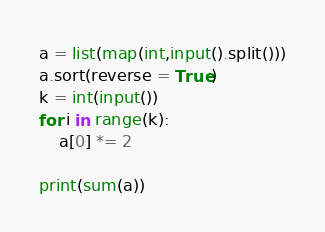Convert code to text. <code><loc_0><loc_0><loc_500><loc_500><_Python_>a = list(map(int,input().split()))
a.sort(reverse = True)
k = int(input())
for i in range(k):
	a[0] *= 2
    
print(sum(a))</code> 